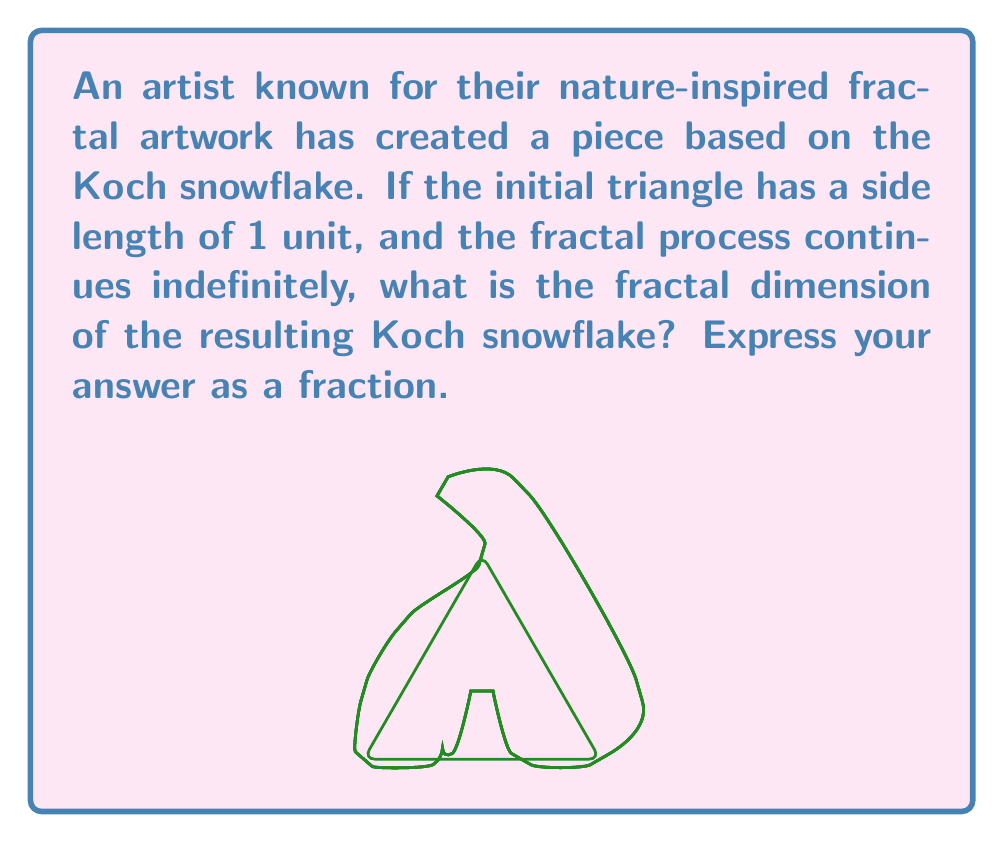Can you solve this math problem? To find the fractal dimension of the Koch snowflake, we'll use the box-counting dimension formula:

$$ D = \frac{\log N}{\log (1/r)} $$

Where:
- $D$ is the fractal dimension
- $N$ is the number of self-similar pieces
- $r$ is the scaling factor

For the Koch snowflake:

1) In each iteration, each line segment is divided into 4 smaller segments.
   So, $N = 4$

2) The length of each new segment is 1/3 of the original.
   So, $r = 1/3$

3) Substituting these values into the formula:

   $$ D = \frac{\log 4}{\log (1/(1/3))} = \frac{\log 4}{\log 3} $$

4) To express this as a fraction, we can use the change of base formula:

   $$ D = \frac{\log 4}{\log 3} = \frac{\log_2 4}{\log_2 3} = \frac{2}{\log_2 3} $$

5) $\log_2 3$ is approximately 1.58496...

   Therefore, $D = \frac{2}{1.58496...} \approx 1.2618...$

6) This can be expressed as the fraction $\frac{\log 4}{\log 3}$

Thus, the fractal dimension of the Koch snowflake is $\frac{\log 4}{\log 3}$.
Answer: $\frac{\log 4}{\log 3}$ 